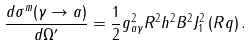<formula> <loc_0><loc_0><loc_500><loc_500>\frac { d \sigma ^ { m } ( \gamma \rightarrow a ) } { d \Omega ^ { \prime } } = \frac { 1 } { 2 } g ^ { 2 } _ { a \gamma } R ^ { 2 } h ^ { 2 } B ^ { 2 } J _ { 1 } ^ { 2 } \left ( R q \right ) .</formula> 